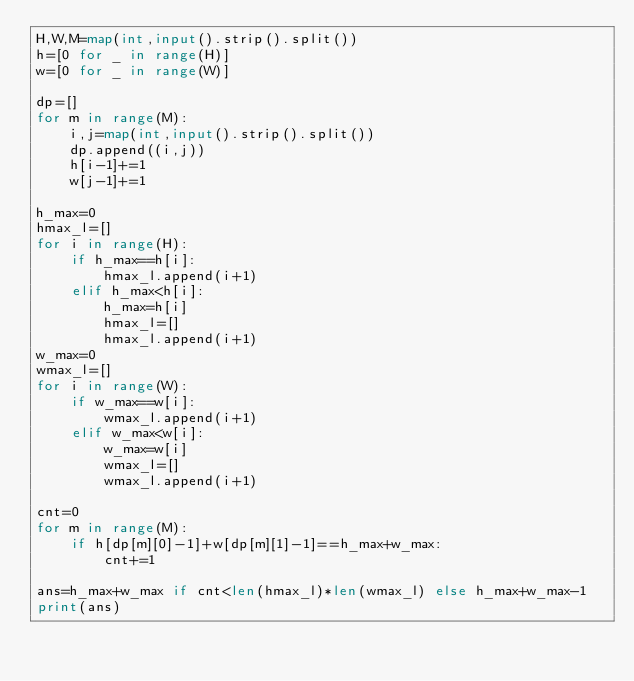<code> <loc_0><loc_0><loc_500><loc_500><_Python_>H,W,M=map(int,input().strip().split())
h=[0 for _ in range(H)]
w=[0 for _ in range(W)]

dp=[]
for m in range(M):
    i,j=map(int,input().strip().split())
    dp.append((i,j))
    h[i-1]+=1
    w[j-1]+=1

h_max=0
hmax_l=[]
for i in range(H):
    if h_max==h[i]:
        hmax_l.append(i+1)
    elif h_max<h[i]:
        h_max=h[i]
        hmax_l=[]
        hmax_l.append(i+1)
w_max=0
wmax_l=[]
for i in range(W):
    if w_max==w[i]:
        wmax_l.append(i+1)
    elif w_max<w[i]:
        w_max=w[i]
        wmax_l=[]
        wmax_l.append(i+1)

cnt=0
for m in range(M):
    if h[dp[m][0]-1]+w[dp[m][1]-1]==h_max+w_max:
        cnt+=1

ans=h_max+w_max if cnt<len(hmax_l)*len(wmax_l) else h_max+w_max-1
print(ans)</code> 